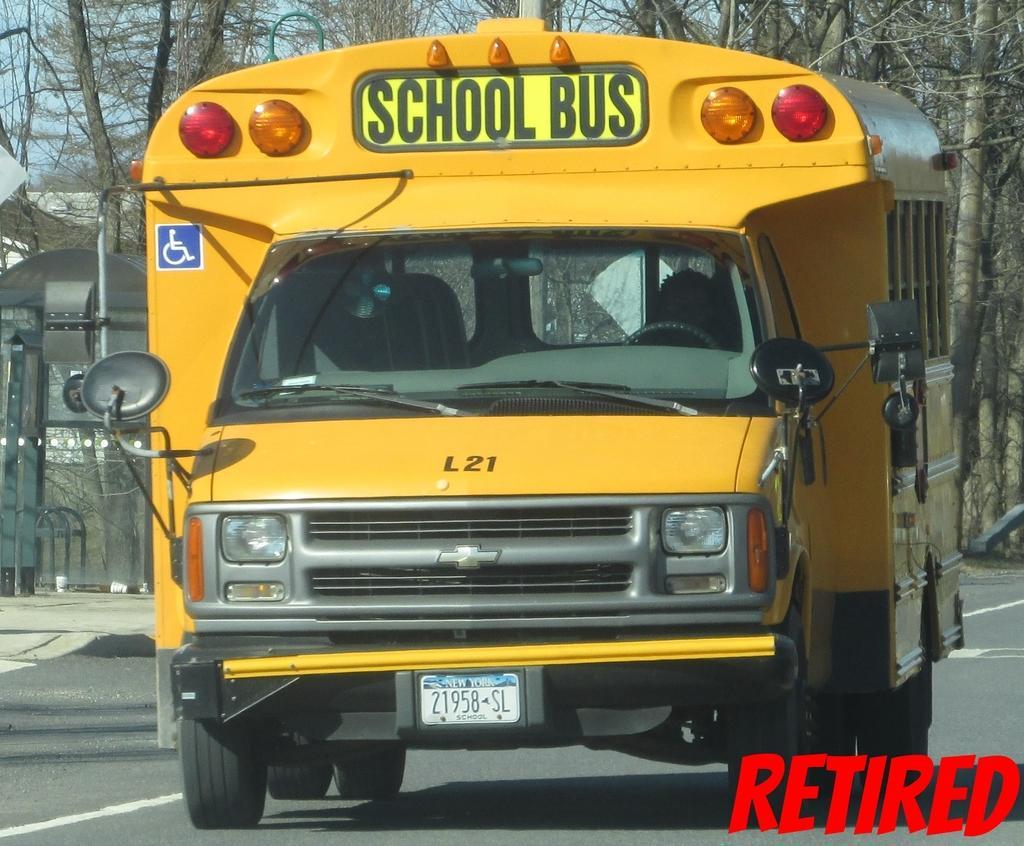In one or two sentences, can you explain what this image depicts? In this image we can see one school bus on the road, some trees in the background, some objects on the ground on the left side of the image, one object on the ground on the right side of the image, some text on the bottom right side of the image, some text on the school bus, number plate with text and numbers attached to the bus. At the top there is the sky. 